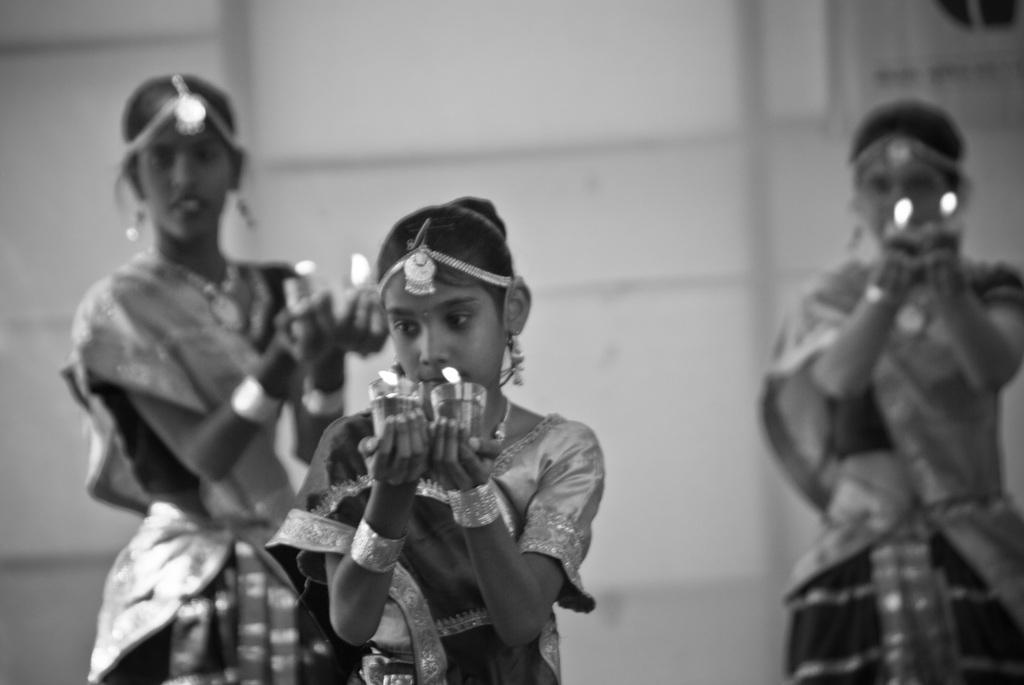How many people are in the image? There are three girls in the image. What are the girls holding in their hands? Each girl is holding a candle in her hand. What type of degree is being awarded to the girls in the image? There is no indication in the image that the girls are receiving a degree or attending a ceremony. 